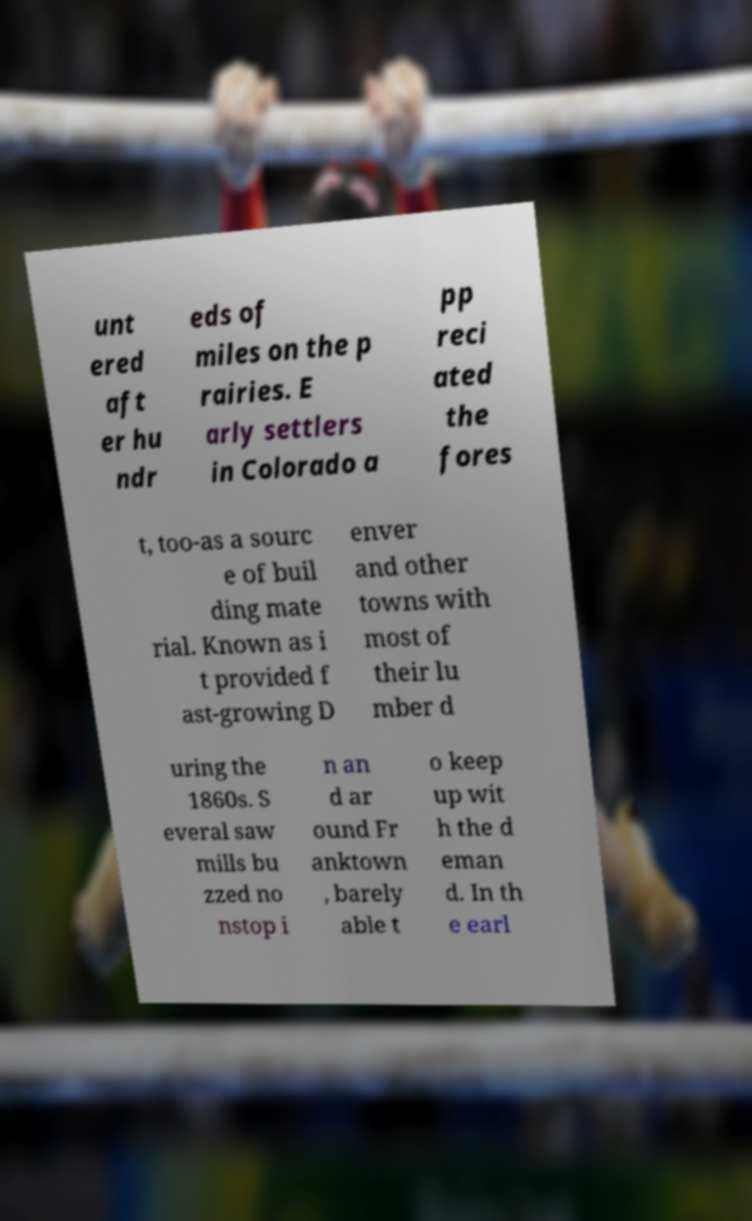Could you extract and type out the text from this image? unt ered aft er hu ndr eds of miles on the p rairies. E arly settlers in Colorado a pp reci ated the fores t, too-as a sourc e of buil ding mate rial. Known as i t provided f ast-growing D enver and other towns with most of their lu mber d uring the 1860s. S everal saw mills bu zzed no nstop i n an d ar ound Fr anktown , barely able t o keep up wit h the d eman d. In th e earl 